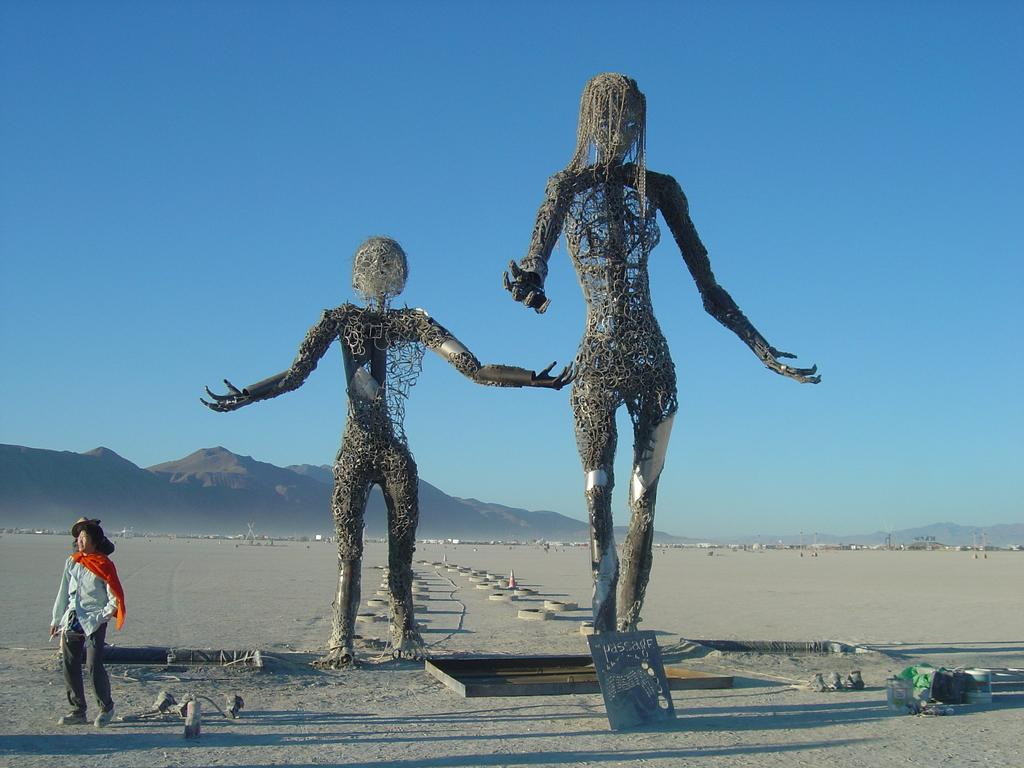What can be seen in the image besides the person? There are two sculptures and some objects visible in the image. What is the setting of the image? The image features mountains in the background. What is the condition of the sky in the image? The sky is visible in the background of the image. How many apples are being held by the rat in the image? There is no rat or apple present in the image. What type of stone is used to create the sculptures in the image? The type of stone used to create the sculptures is not mentioned in the image. 